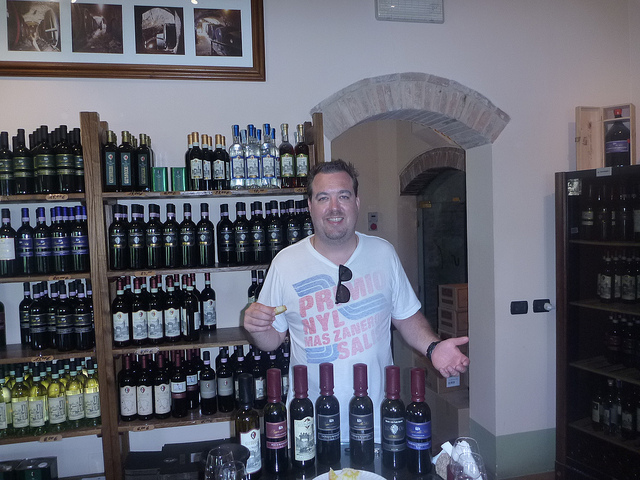<image>How many wines are merlo? I am unsure how many of the wines are Merlo. How many wines are merlo? I don't know how many wines are merlot. It can be any number. 